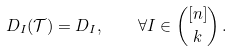<formula> <loc_0><loc_0><loc_500><loc_500>D _ { I } ( \mathcal { T } ) = D _ { I } , \quad \forall I \in { [ n ] \choose k } \, .</formula> 